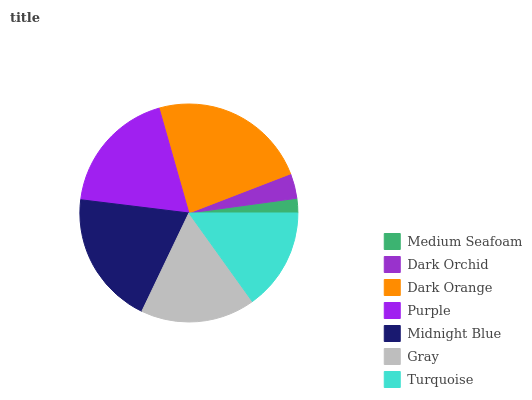Is Medium Seafoam the minimum?
Answer yes or no. Yes. Is Dark Orange the maximum?
Answer yes or no. Yes. Is Dark Orchid the minimum?
Answer yes or no. No. Is Dark Orchid the maximum?
Answer yes or no. No. Is Dark Orchid greater than Medium Seafoam?
Answer yes or no. Yes. Is Medium Seafoam less than Dark Orchid?
Answer yes or no. Yes. Is Medium Seafoam greater than Dark Orchid?
Answer yes or no. No. Is Dark Orchid less than Medium Seafoam?
Answer yes or no. No. Is Gray the high median?
Answer yes or no. Yes. Is Gray the low median?
Answer yes or no. Yes. Is Turquoise the high median?
Answer yes or no. No. Is Turquoise the low median?
Answer yes or no. No. 